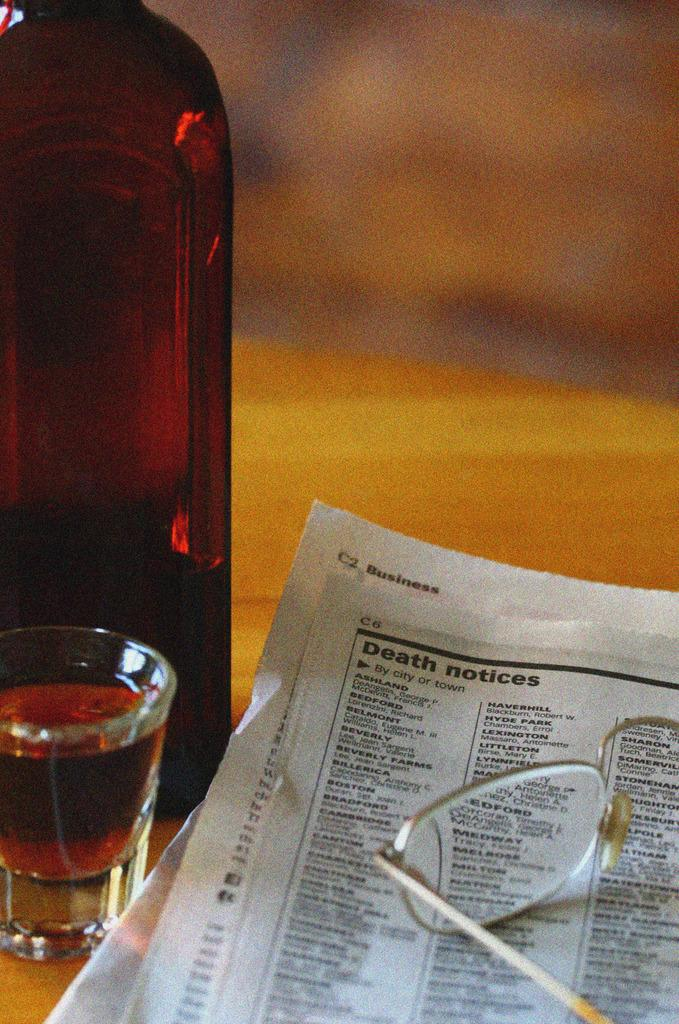<image>
Relay a brief, clear account of the picture shown. A set of glasses and a shot of liquor next to a newspaper section titled Death notices 